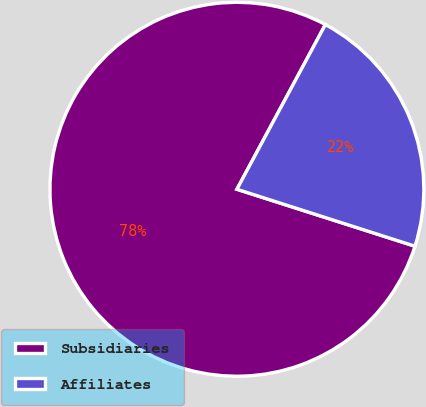<chart> <loc_0><loc_0><loc_500><loc_500><pie_chart><fcel>Subsidiaries<fcel>Affiliates<nl><fcel>77.92%<fcel>22.08%<nl></chart> 